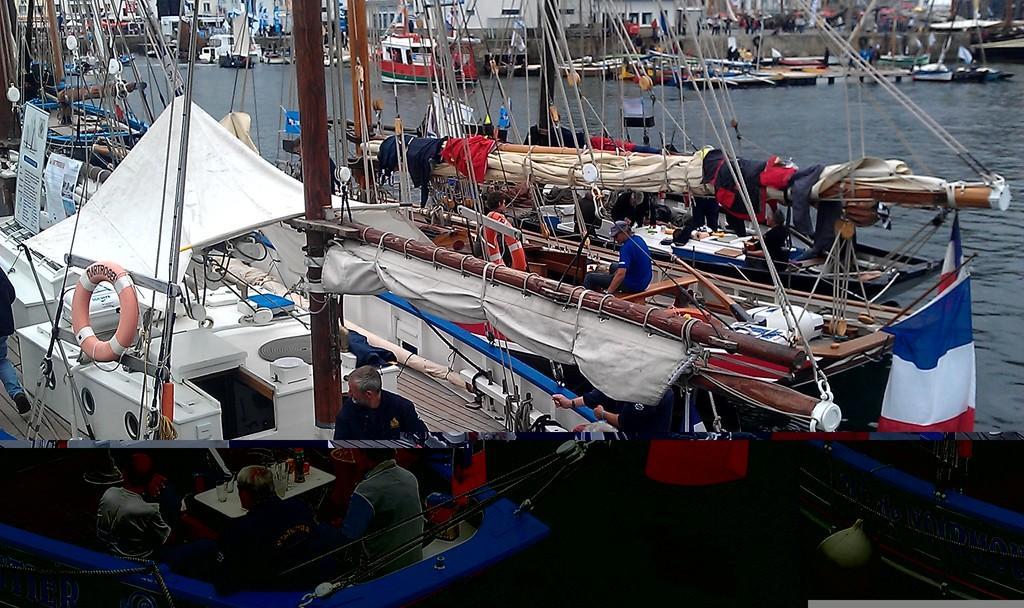Please provide a concise description of this image. In this image we can see ships on the water and there are people in the ships. 